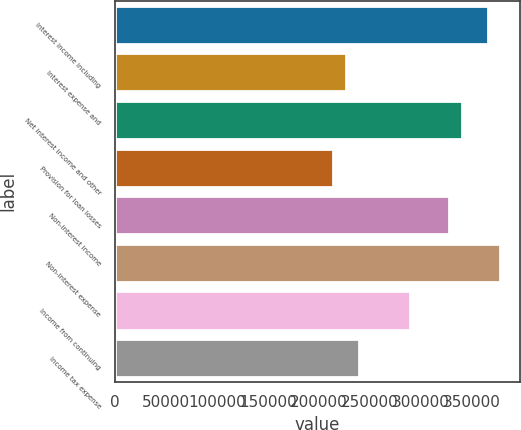Convert chart. <chart><loc_0><loc_0><loc_500><loc_500><bar_chart><fcel>Interest income including<fcel>Interest expense and<fcel>Net interest income and other<fcel>Provision for loan losses<fcel>Non-interest income<fcel>Non-interest expense<fcel>Income from continuing<fcel>Income tax expense<nl><fcel>365544<fcel>226889<fcel>340334<fcel>214284<fcel>327729<fcel>378148<fcel>289914<fcel>239494<nl></chart> 